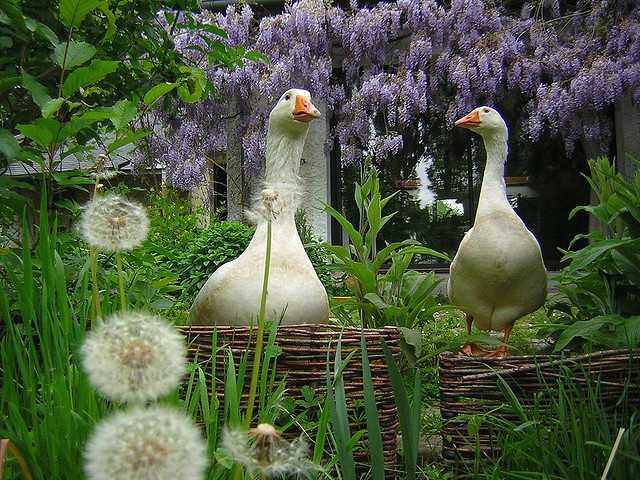Describe the objects in this image and their specific colors. I can see bird in darkgreen, beige, darkgray, and gray tones and bird in darkgreen, darkgray, black, and gray tones in this image. 